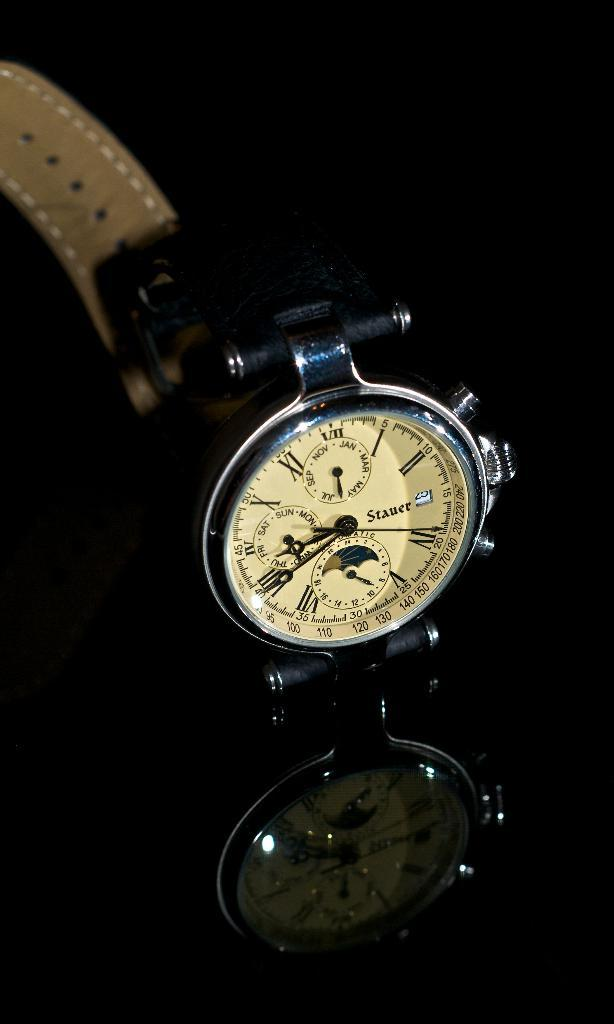Provide a one-sentence caption for the provided image. Face of a watch which says "STAUER" on it. 